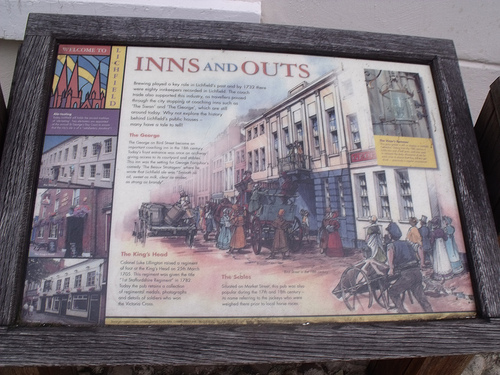<image>
Is the frame behind the sign? No. The frame is not behind the sign. From this viewpoint, the frame appears to be positioned elsewhere in the scene. 